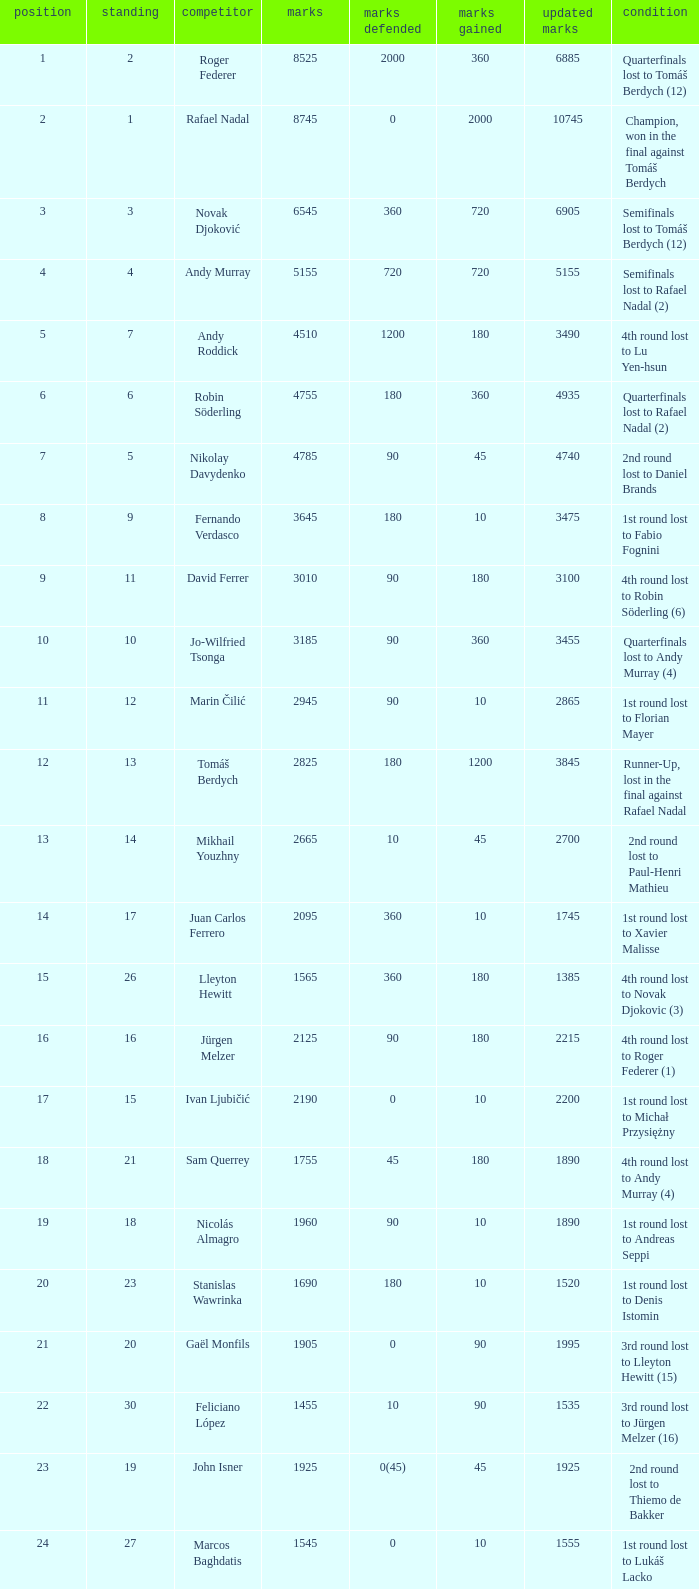Name the number of points defending for 1075 1.0. 